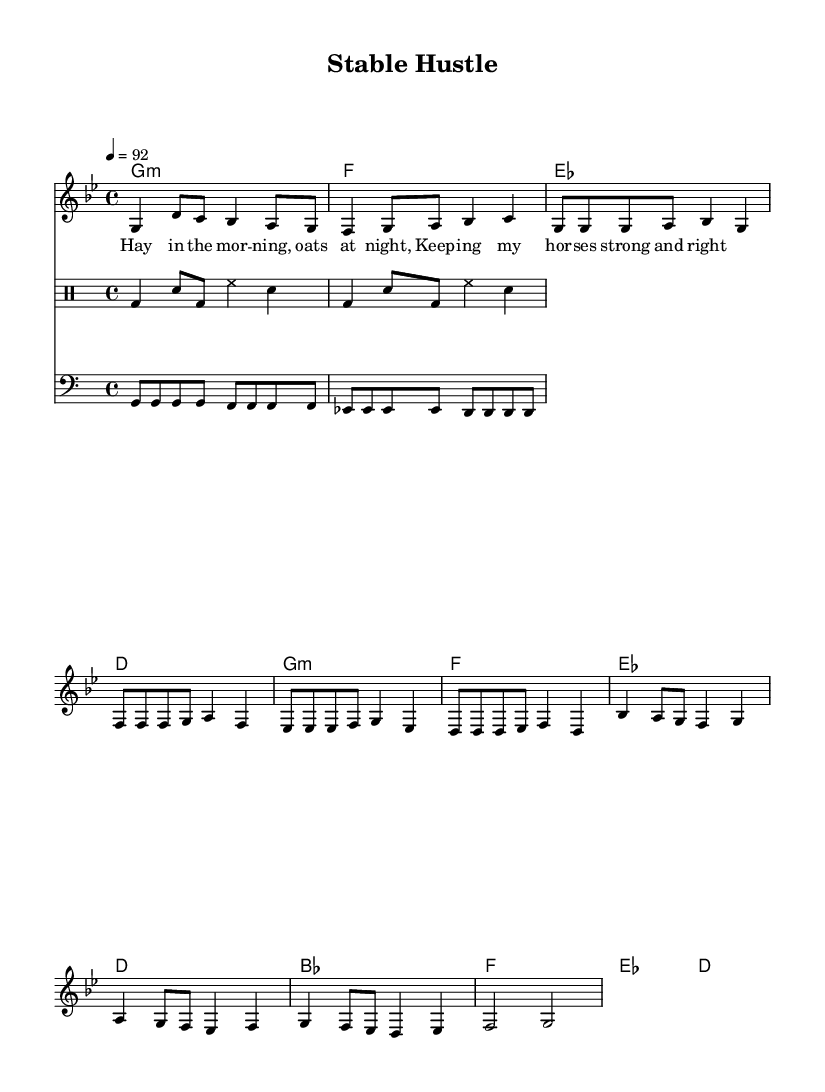What is the key signature of this music? The music is in G minor, which has two flats (B flat and E flat). This information can be determined from the key signature indicated at the beginning of the staff.
Answer: G minor What is the time signature of this piece? The time signature is 4/4, common in many music genres, including Hip Hop. It is indicated at the start of the music notation and is typically recognizable by the two numbers stacked on top of each other.
Answer: 4/4 What is the tempo of the music? The tempo is set at 92 beats per minute, as shown by the marking "4 = 92" which provides the speed at which the piece should be played.
Answer: 92 How many measures are there in the verse section? The verse contains 4 measures, which can be identified by counting the number of groups of four beats (or sets of notes) in the verse section specifically indicated in the sheet music.
Answer: 4 What is the first note of the melody? The first note of the melody is G, which appears at the beginning of the melody line when the music starts.
Answer: G What type of instrumental accompaniment is indicated in this piece? The accompaniment includes a drum pattern, which defines the rhythmic structure of the Hip Hop genre, showcased in the drum staff written in the drummode section.
Answer: Drum pattern What themes are reflected in the lyrics of this song? The lyrics reflect themes of caring for horses, highlighting the daily routines like feeding them hay and oats. This is directly tied to perceptions of animal husbandry, which is common in Hip Hop storytelling.
Answer: Animal husbandry 